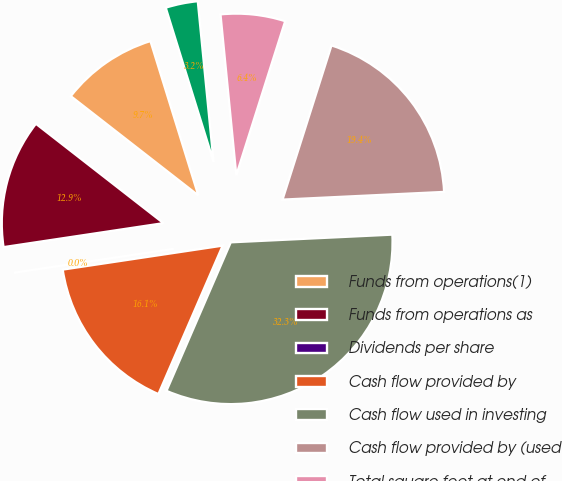Convert chart. <chart><loc_0><loc_0><loc_500><loc_500><pie_chart><fcel>Funds from operations(1)<fcel>Funds from operations as<fcel>Dividends per share<fcel>Cash flow provided by<fcel>Cash flow used in investing<fcel>Cash flow provided by (used<fcel>Total square feet at end of<fcel>Occupancy rate at end of year<nl><fcel>9.68%<fcel>12.9%<fcel>0.0%<fcel>16.13%<fcel>32.26%<fcel>19.35%<fcel>6.45%<fcel>3.23%<nl></chart> 